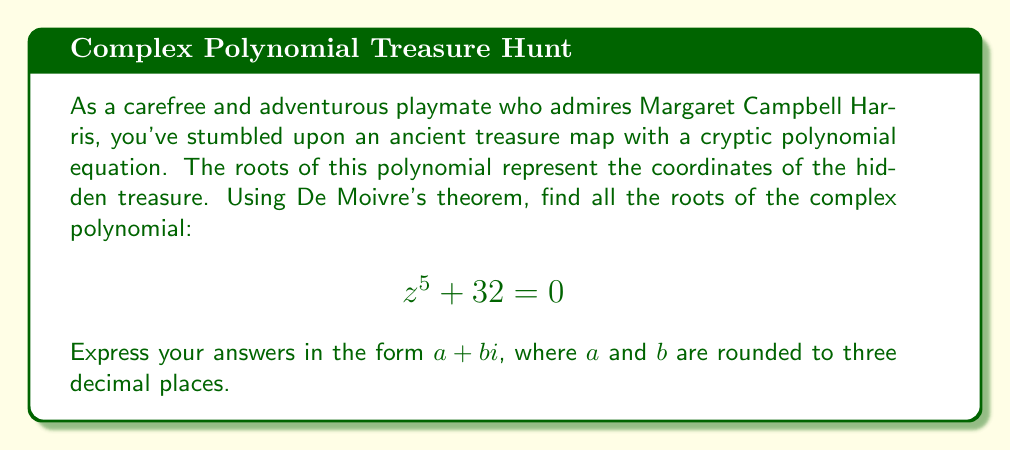Give your solution to this math problem. Let's approach this step-by-step using De Moivre's theorem:

1) First, we rearrange the equation to standard form:
   $$z^5 = -32$$

2) We can write this in polar form:
   $$z^5 = 32(\cos\pi + i\sin\pi)$$

3) Using De Moivre's theorem, we know that the roots are given by:
   $$z_k = \sqrt[5]{32} \left(\cos\frac{\pi + 2k\pi}{5} + i\sin\frac{\pi + 2k\pi}{5}\right)$$
   where $k = 0, 1, 2, 3, 4$

4) Calculate $\sqrt[5]{32} = 2$

5) Now, let's calculate each root:

   For $k = 0$:
   $$z_0 = 2\left(\cos\frac{\pi}{5} + i\sin\frac{\pi}{5}\right)$$
   $$= 2(\cos36° + i\sin36°) \approx 1.618 + 1.176i$$

   For $k = 1$:
   $$z_1 = 2\left(\cos\frac{3\pi}{5} + i\sin\frac{3\pi}{5}\right)$$
   $$= 2(\cos108° + i\sin108°) \approx -0.618 + 1.902i$$

   For $k = 2$:
   $$z_2 = 2\left(\cos\pi + i\sin\pi\right) = -2$$

   For $k = 3$:
   $$z_3 = 2\left(\cos\frac{7\pi}{5} + i\sin\frac{7\pi}{5}\right)$$
   $$= 2(\cos252° + i\sin252°) \approx -0.618 - 1.902i$$

   For $k = 4$:
   $$z_4 = 2\left(\cos\frac{9\pi}{5} + i\sin\frac{9\pi}{5}\right)$$
   $$= 2(\cos324° + i\sin324°) \approx 1.618 - 1.176i$$

6) Rounding to three decimal places gives us our final answers.
Answer: The roots of the polynomial $z^5 + 32 = 0$ are:

$z_0 \approx 1.618 + 1.176i$
$z_1 \approx -0.618 + 1.902i$
$z_2 = -2$
$z_3 \approx -0.618 - 1.902i$
$z_4 \approx 1.618 - 1.176i$ 